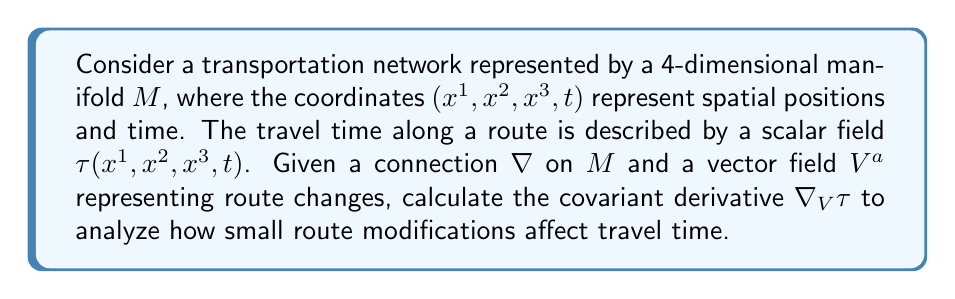Can you answer this question? To solve this problem, we'll follow these steps:

1) The covariant derivative of a scalar field $\tau$ with respect to a vector field $V^a$ is given by:

   $$\nabla_V \tau = V^a \nabla_a \tau$$

2) For a scalar field, the covariant derivative reduces to the partial derivative:

   $$\nabla_a \tau = \partial_a \tau$$

3) Therefore, we can express the covariant derivative as:

   $$\nabla_V \tau = V^a \partial_a \tau$$

4) Expanding this in our 4-dimensional coordinate system:

   $$\nabla_V \tau = V^1 \frac{\partial \tau}{\partial x^1} + V^2 \frac{\partial \tau}{\partial x^2} + V^3 \frac{\partial \tau}{\partial x^3} + V^4 \frac{\partial \tau}{\partial t}$$

5) This expression gives us the rate of change of travel time $\tau$ in the direction of the route change vector $V^a$.

6) To interpret this result:
   - $V^1, V^2, V^3$ represent spatial changes in the route
   - $V^4$ represents temporal changes (e.g., departure time adjustments)
   - Each term $V^i \frac{\partial \tau}{\partial x^i}$ shows how much the travel time changes due to route modifications in the $i$-th direction

7) The magnitude of $\nabla_V \tau$ indicates the sensitivity of travel time to the proposed route change, while its sign shows whether the change increases or decreases travel time.
Answer: $\nabla_V \tau = V^a \partial_a \tau = V^1 \frac{\partial \tau}{\partial x^1} + V^2 \frac{\partial \tau}{\partial x^2} + V^3 \frac{\partial \tau}{\partial x^3} + V^4 \frac{\partial \tau}{\partial t}$ 